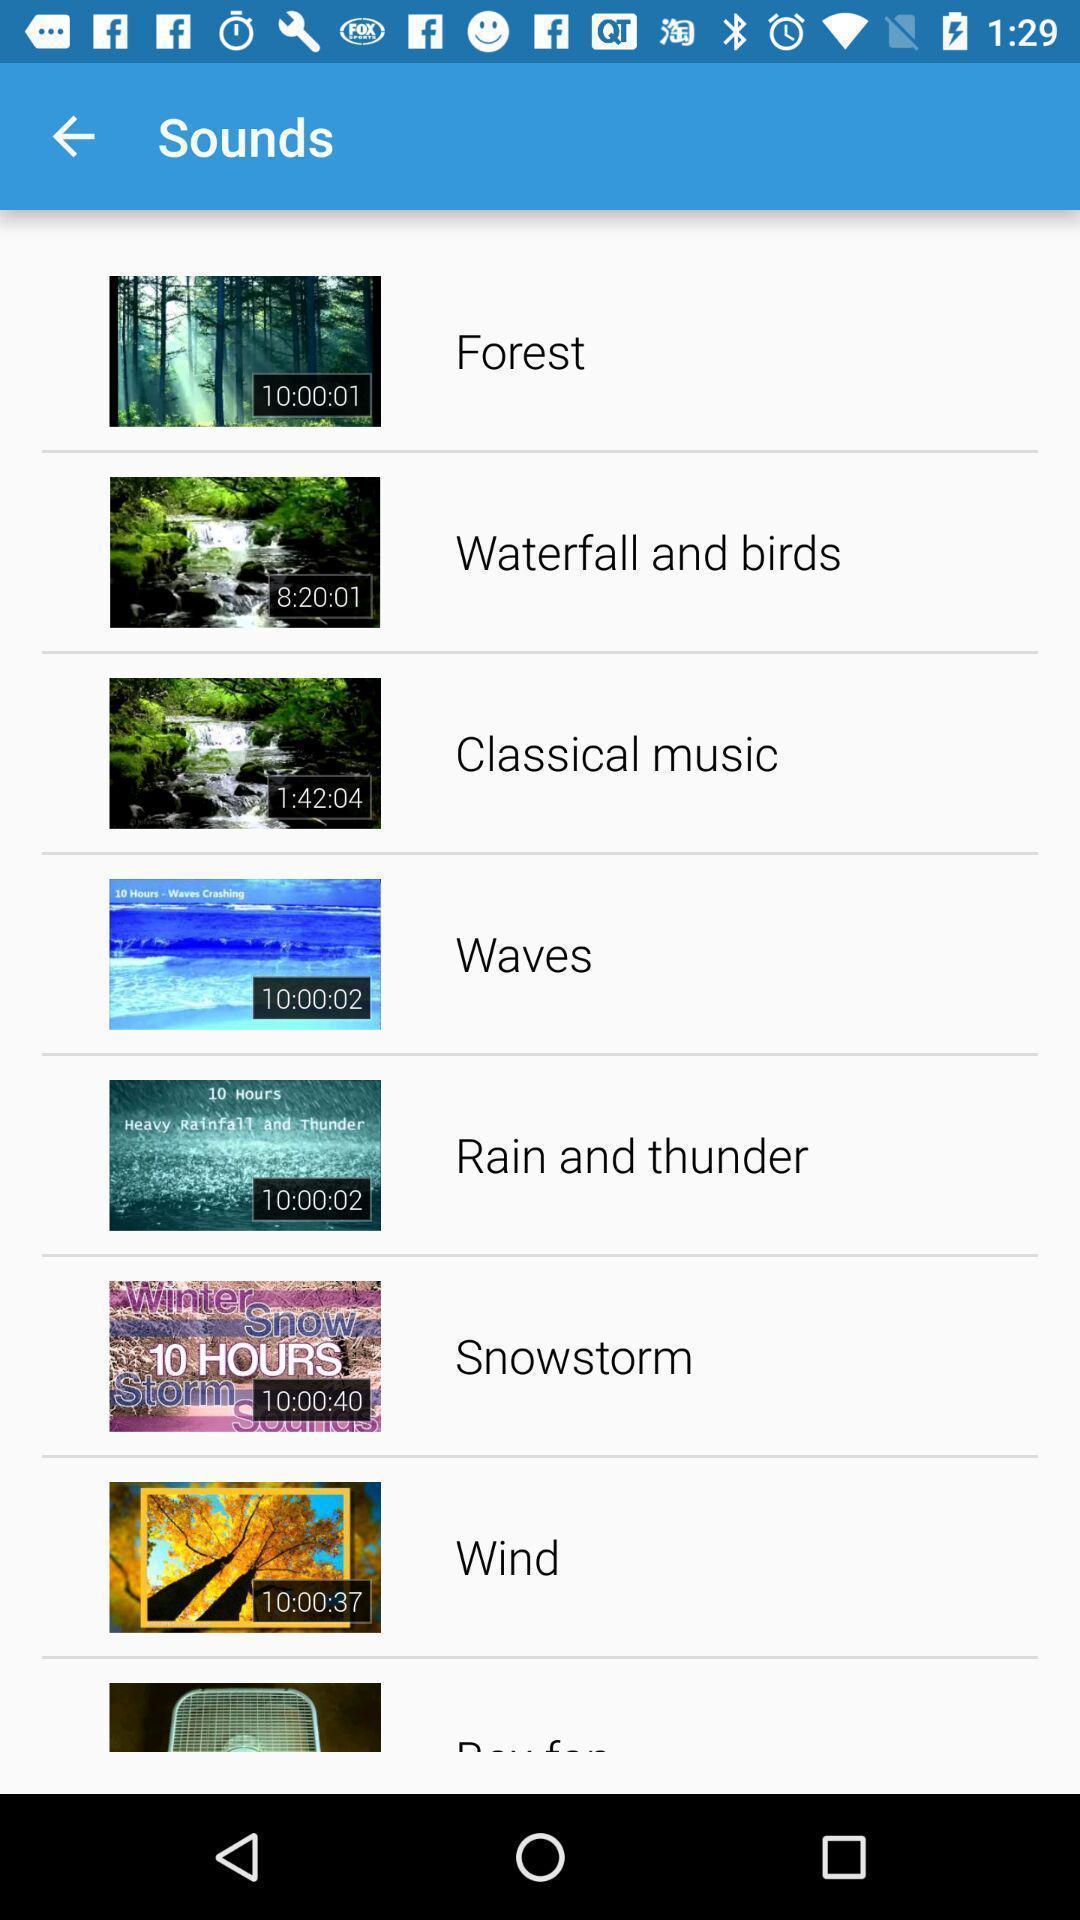What can you discern from this picture? Screen shows list of sounds. 